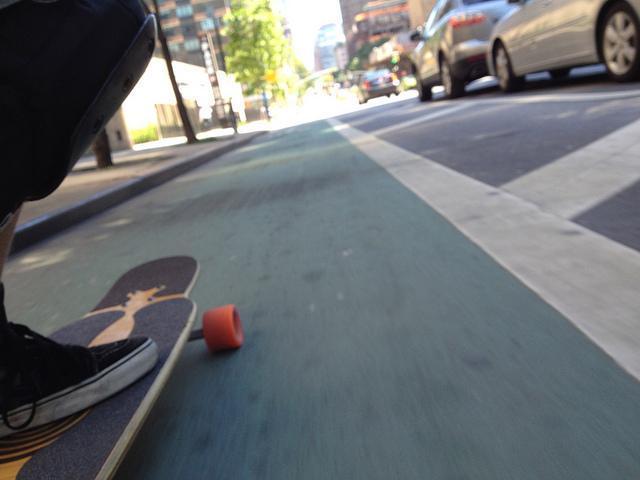What is on top of the skateboard?
Select the accurate response from the four choices given to answer the question.
Options: Elephant, cat, sneaker, dog paw. Sneaker. 